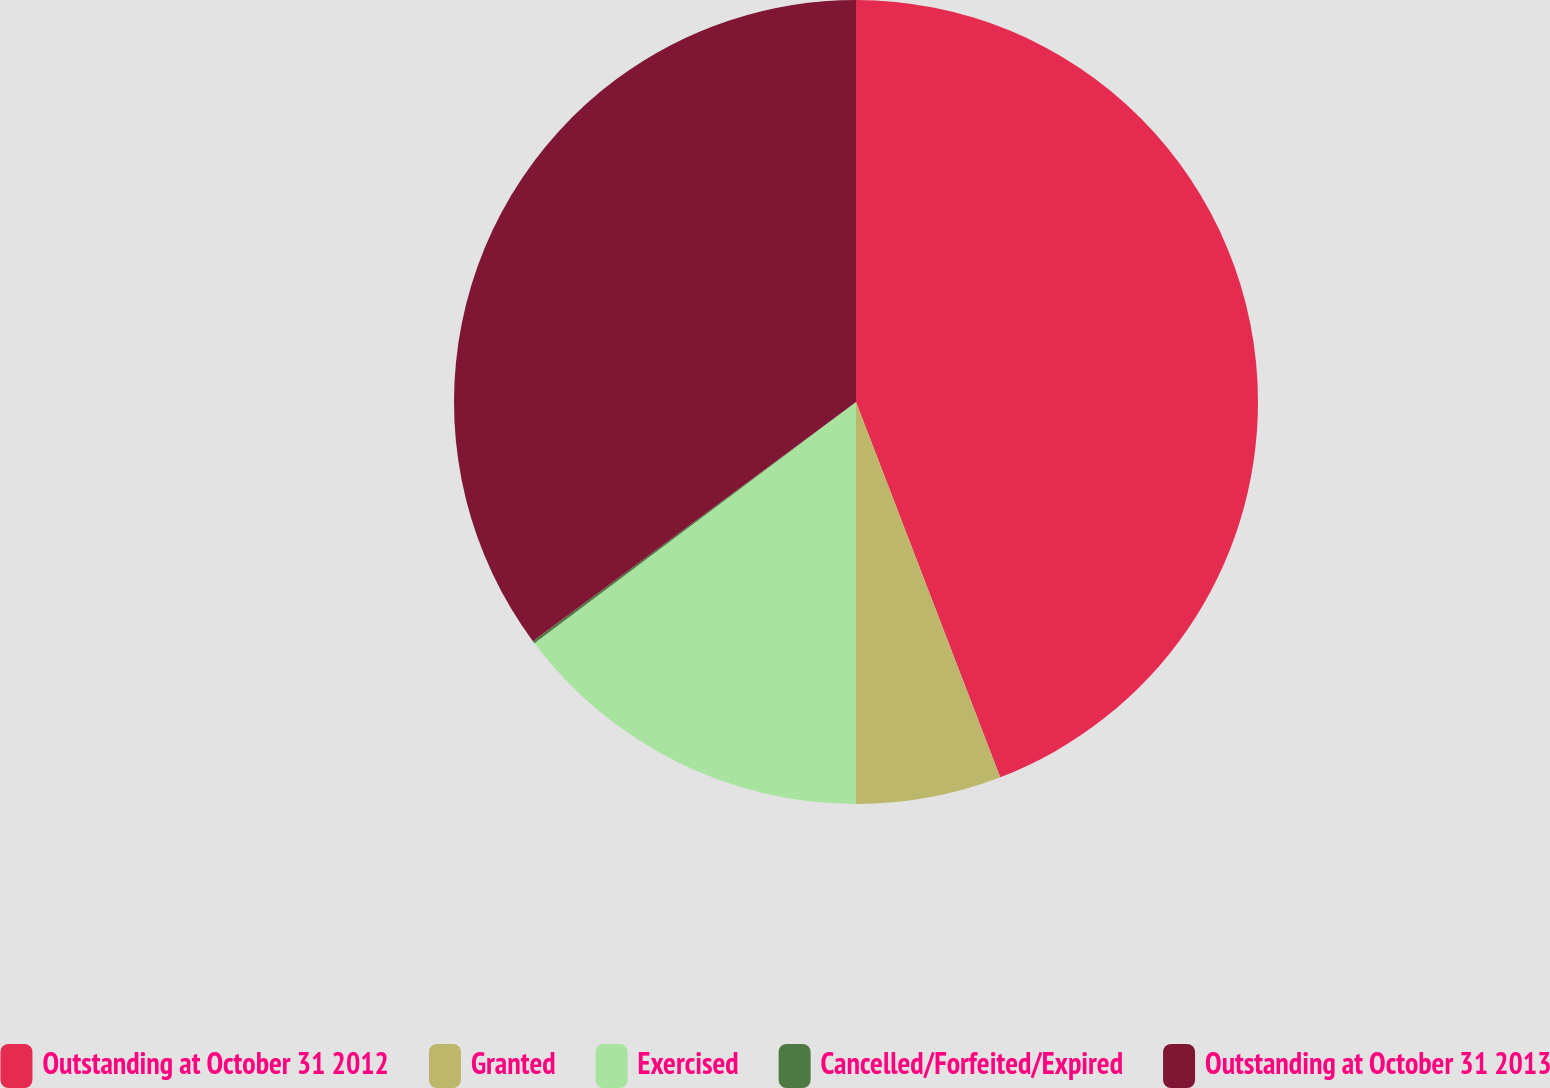<chart> <loc_0><loc_0><loc_500><loc_500><pie_chart><fcel>Outstanding at October 31 2012<fcel>Granted<fcel>Exercised<fcel>Cancelled/Forfeited/Expired<fcel>Outstanding at October 31 2013<nl><fcel>44.16%<fcel>5.84%<fcel>14.76%<fcel>0.1%<fcel>35.14%<nl></chart> 